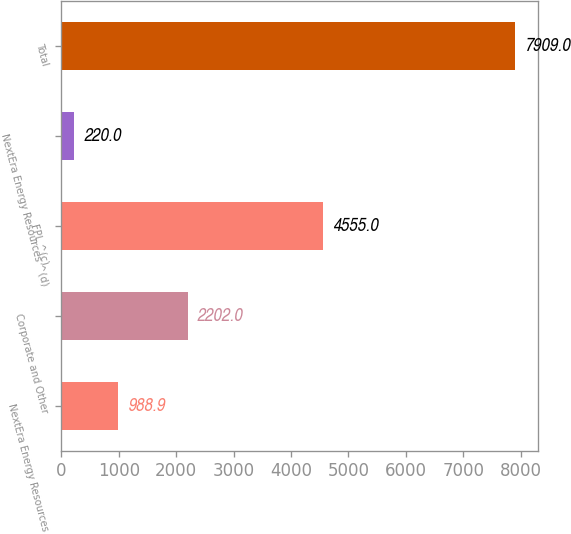Convert chart to OTSL. <chart><loc_0><loc_0><loc_500><loc_500><bar_chart><fcel>NextEra Energy Resources<fcel>Corporate and Other<fcel>FPL ^(c)<fcel>NextEra Energy Resources ^(d)<fcel>Total<nl><fcel>988.9<fcel>2202<fcel>4555<fcel>220<fcel>7909<nl></chart> 